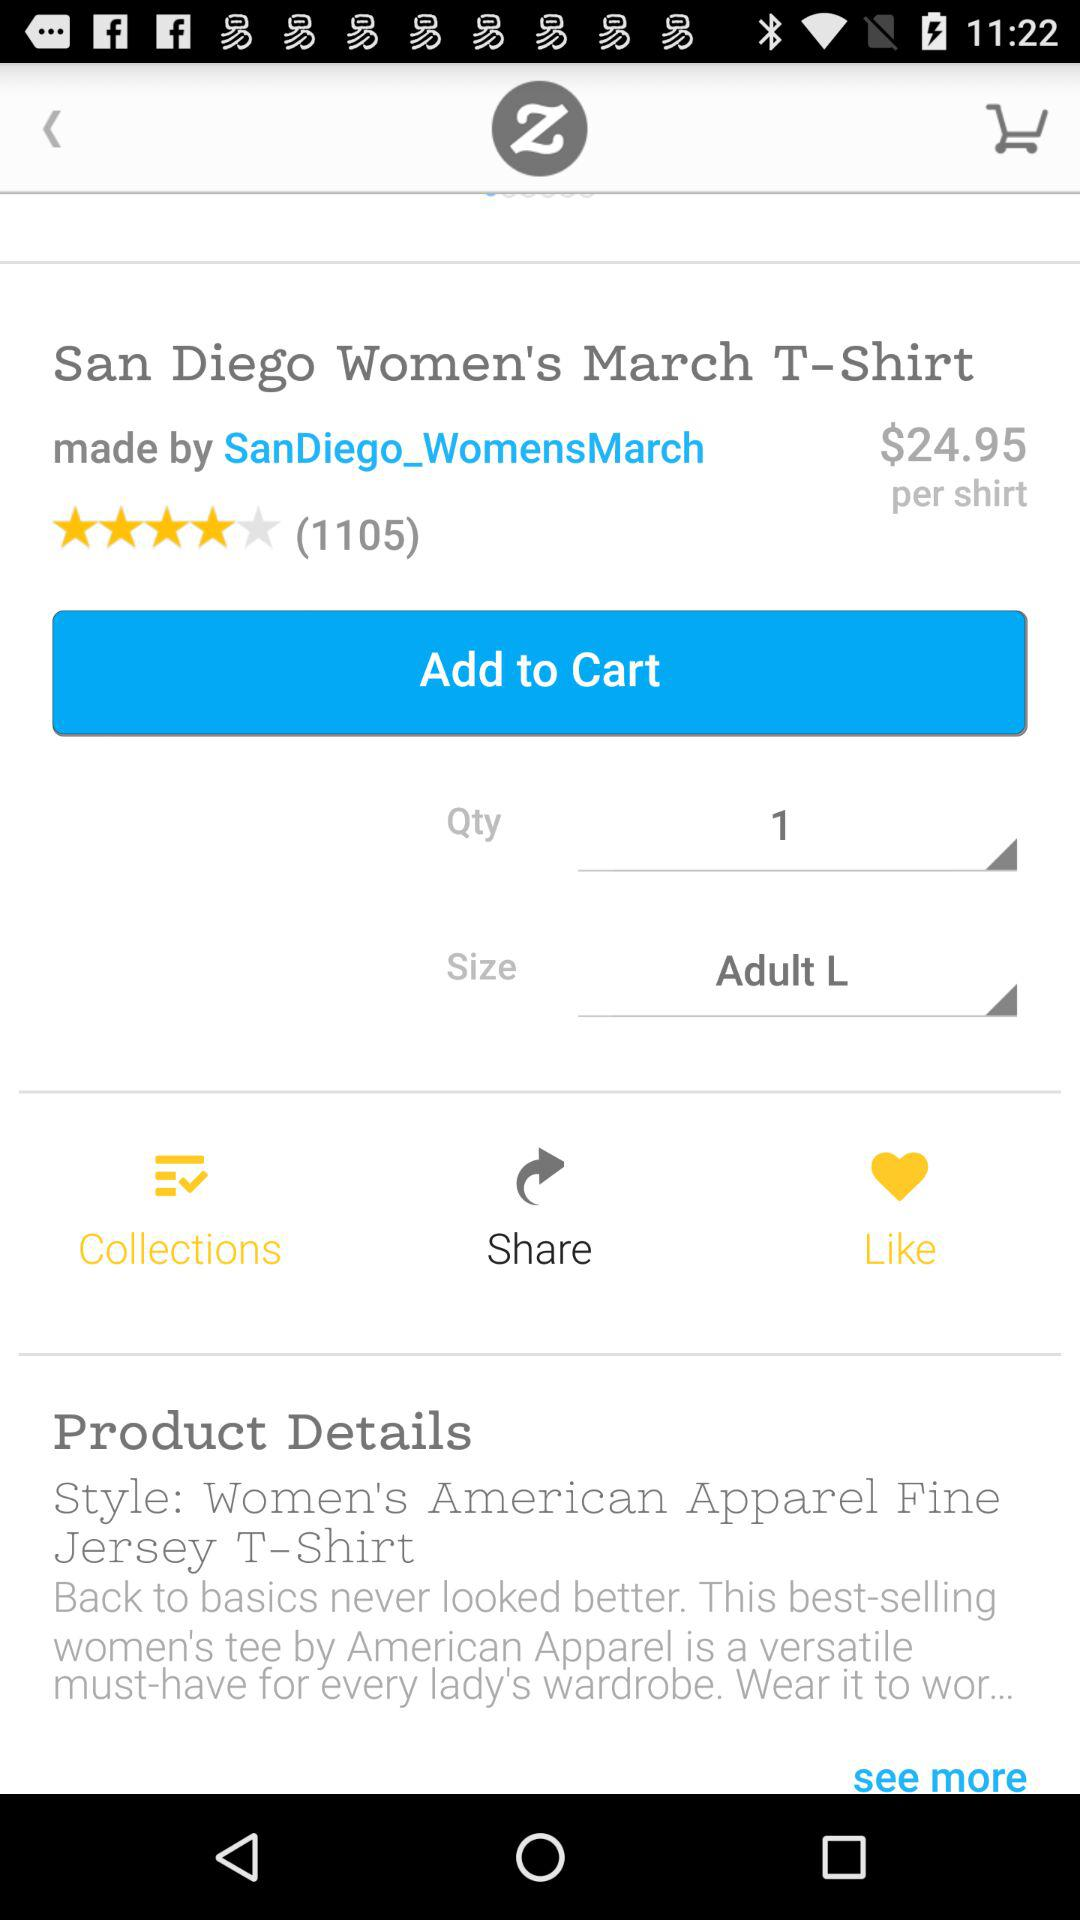Who is the designer of the t-shirt? The designer of the t-shirt is "SanDiego_WomensMarch". 